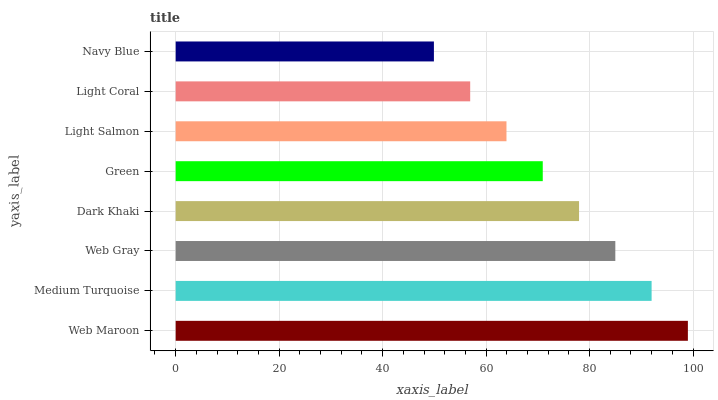Is Navy Blue the minimum?
Answer yes or no. Yes. Is Web Maroon the maximum?
Answer yes or no. Yes. Is Medium Turquoise the minimum?
Answer yes or no. No. Is Medium Turquoise the maximum?
Answer yes or no. No. Is Web Maroon greater than Medium Turquoise?
Answer yes or no. Yes. Is Medium Turquoise less than Web Maroon?
Answer yes or no. Yes. Is Medium Turquoise greater than Web Maroon?
Answer yes or no. No. Is Web Maroon less than Medium Turquoise?
Answer yes or no. No. Is Dark Khaki the high median?
Answer yes or no. Yes. Is Green the low median?
Answer yes or no. Yes. Is Green the high median?
Answer yes or no. No. Is Light Coral the low median?
Answer yes or no. No. 